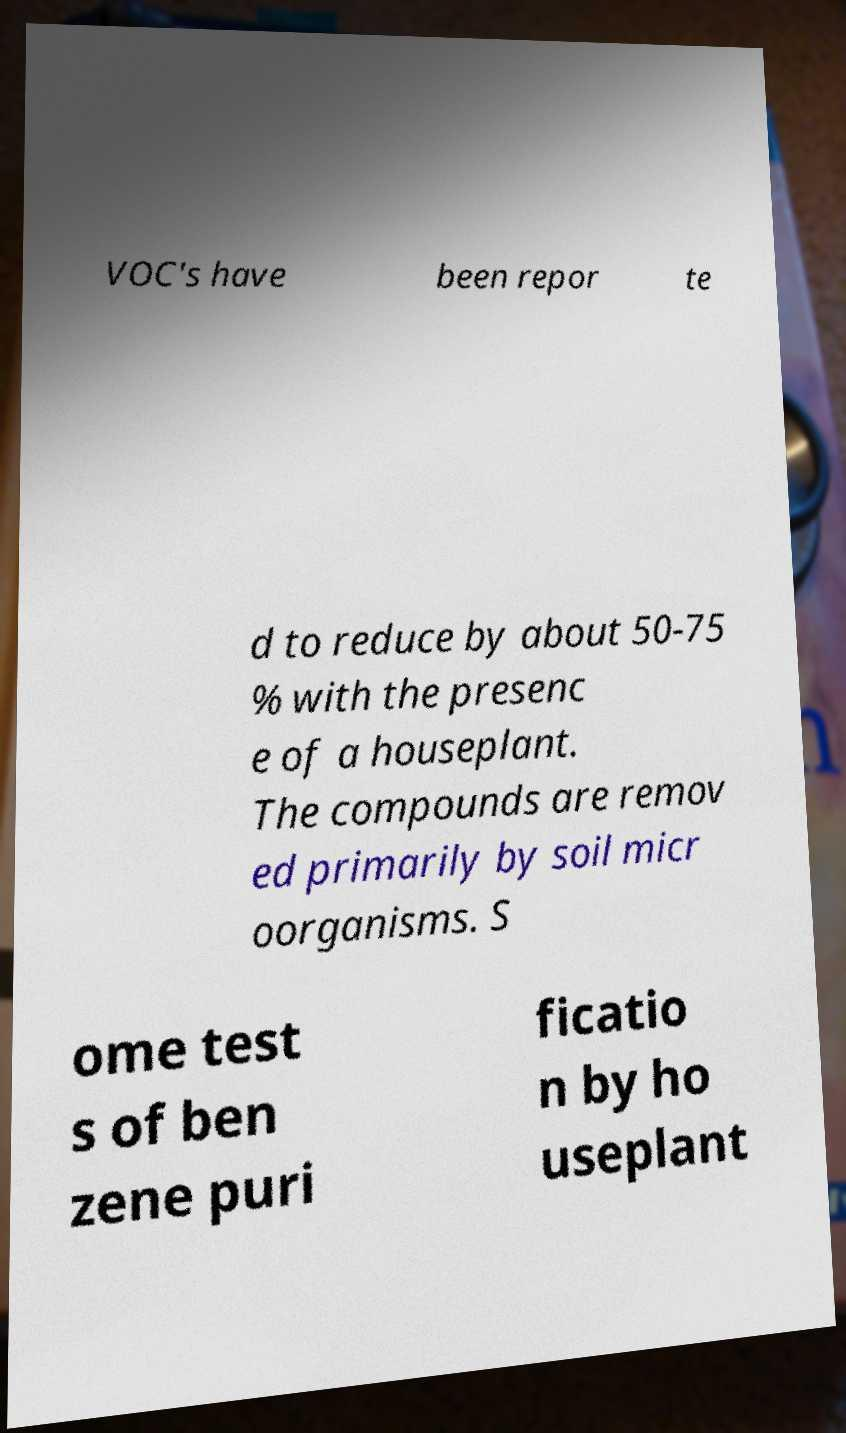Please read and relay the text visible in this image. What does it say? VOC's have been repor te d to reduce by about 50-75 % with the presenc e of a houseplant. The compounds are remov ed primarily by soil micr oorganisms. S ome test s of ben zene puri ficatio n by ho useplant 